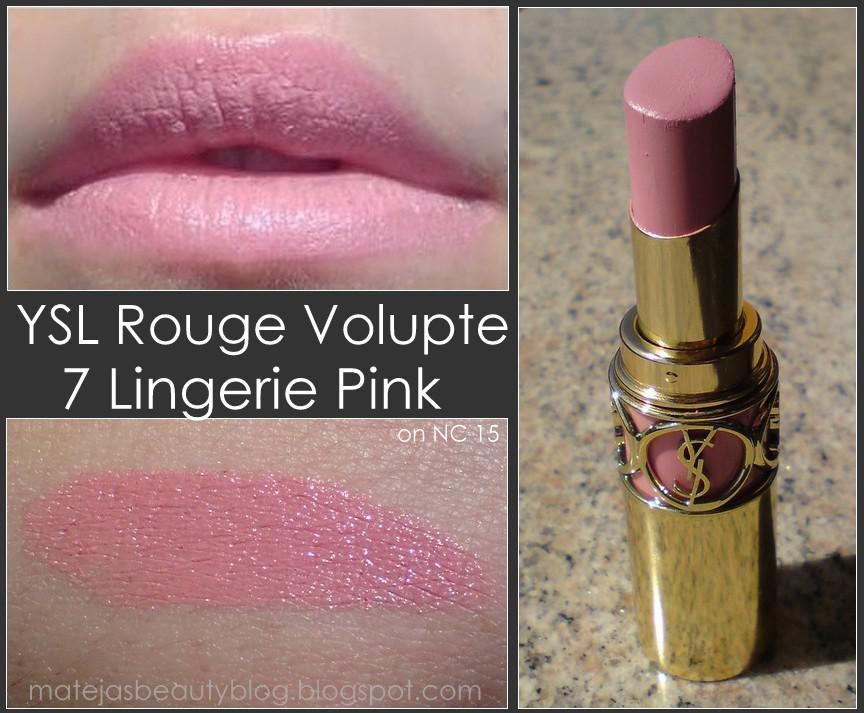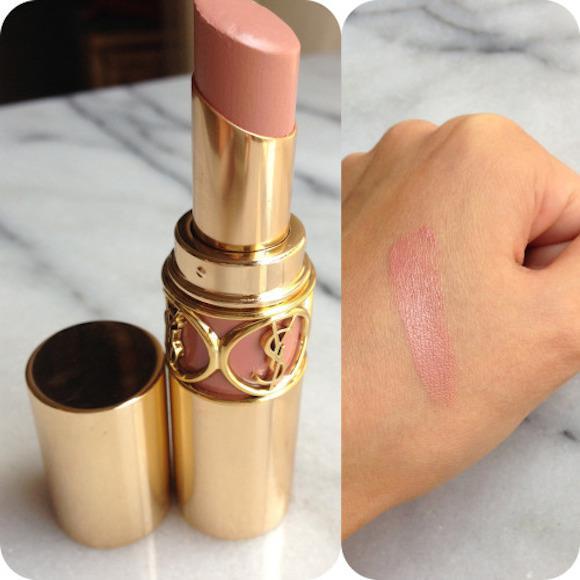The first image is the image on the left, the second image is the image on the right. For the images displayed, is the sentence "YSL Rouge Volupte #2 is featured." factually correct? Answer yes or no. No. 